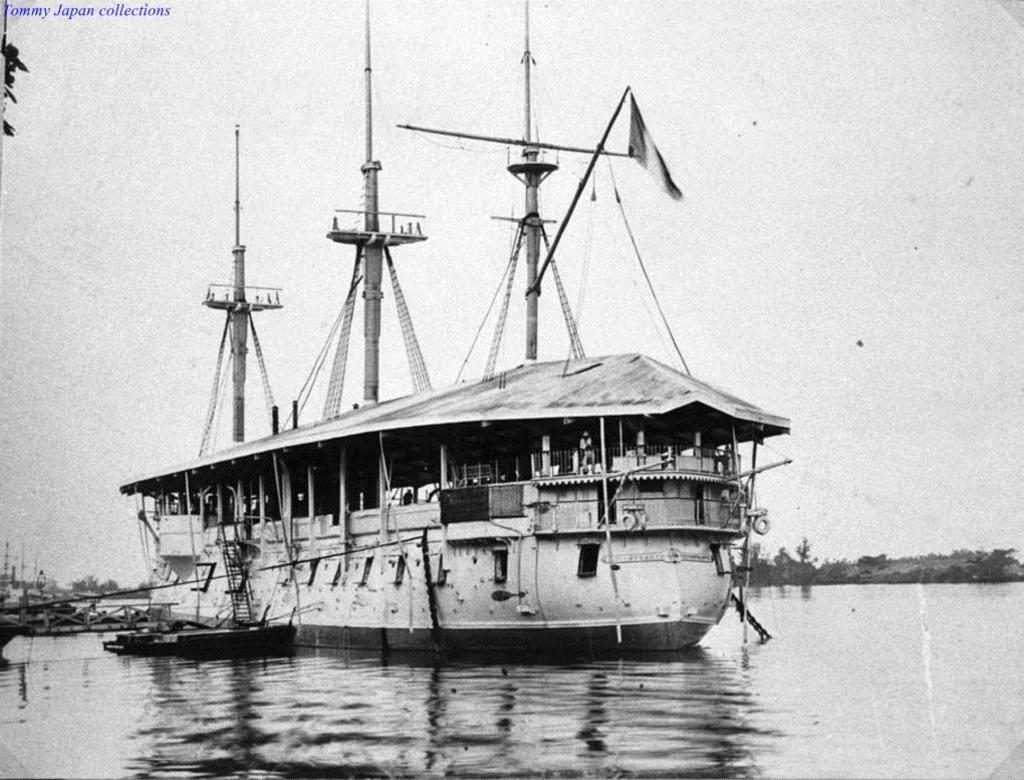What is the main subject of the image? There is a boat in the image. Where is the boat located? The boat is on the water. What can be seen in the background of the image? There are trees and the sky visible in the background of the image. How is the image presented in terms of color? The image is black and white. How many eyes can be seen on the boat in the image? There are no eyes visible on the boat in the image, as boats do not have eyes. Is the boat in the image taking a nap or sleeping? Boats do not sleep or take naps, so this question cannot be answered based on the image. 